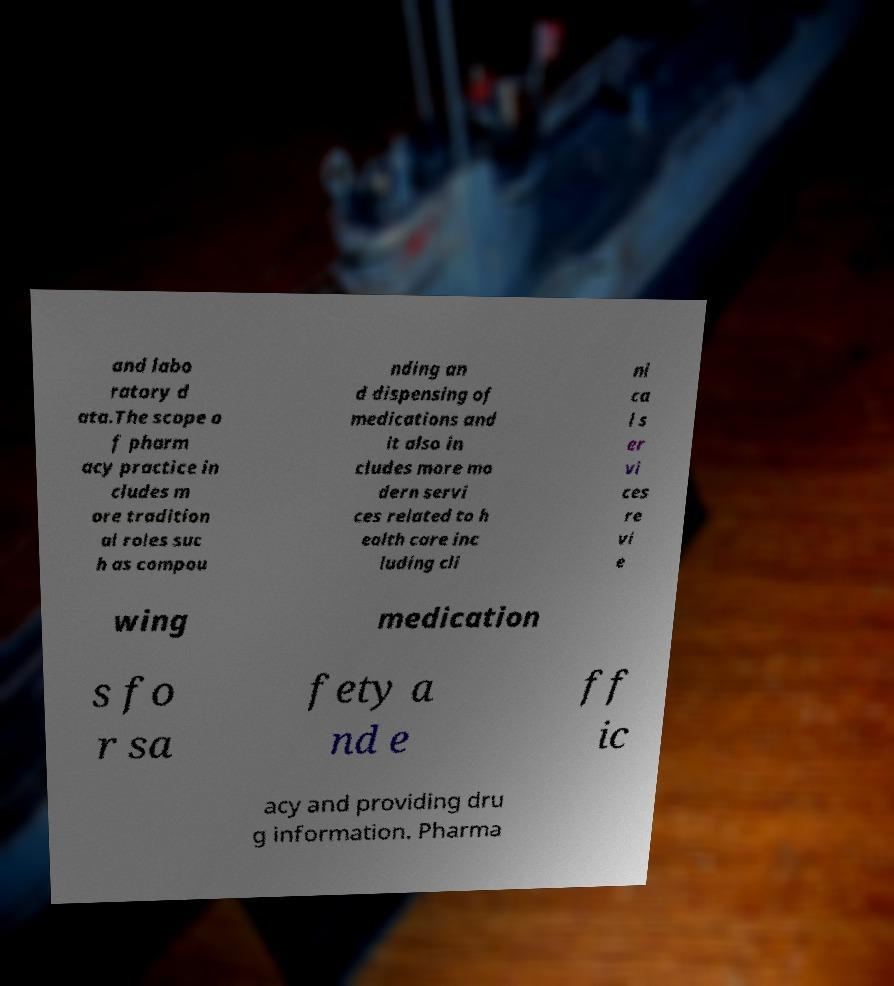Could you assist in decoding the text presented in this image and type it out clearly? and labo ratory d ata.The scope o f pharm acy practice in cludes m ore tradition al roles suc h as compou nding an d dispensing of medications and it also in cludes more mo dern servi ces related to h ealth care inc luding cli ni ca l s er vi ces re vi e wing medication s fo r sa fety a nd e ff ic acy and providing dru g information. Pharma 